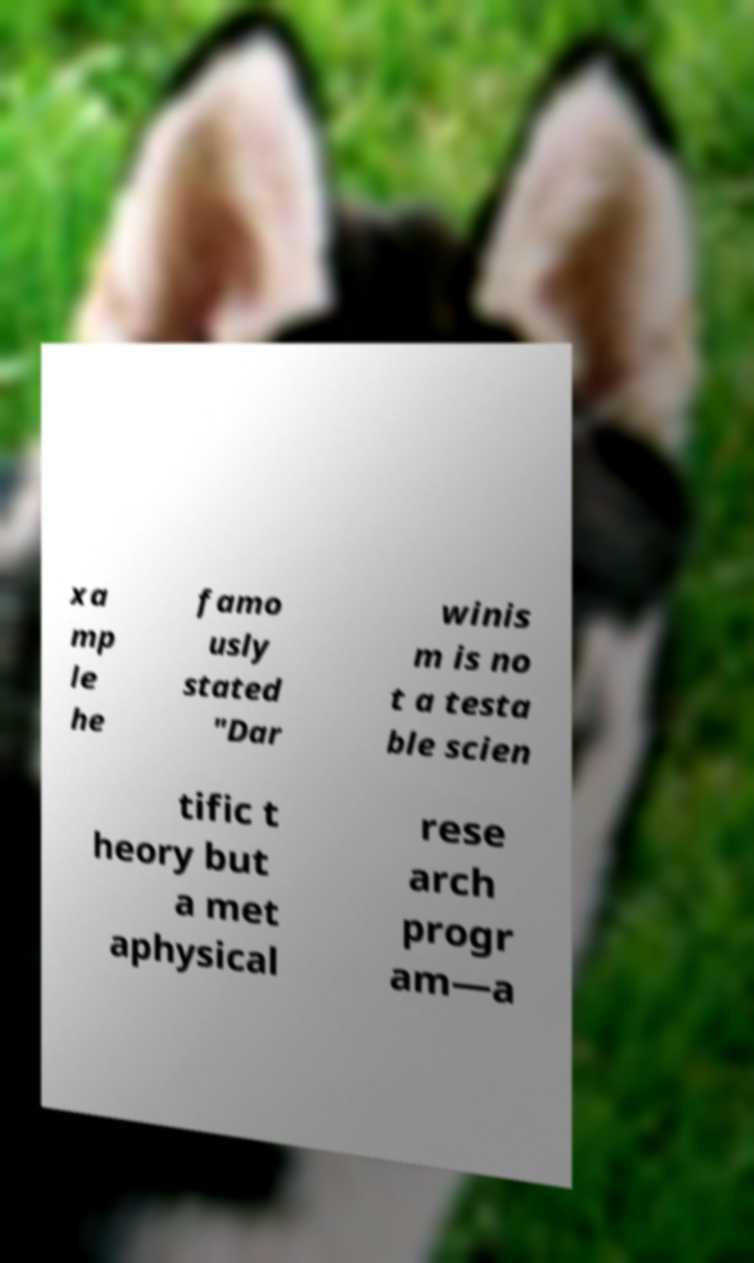Could you extract and type out the text from this image? xa mp le he famo usly stated "Dar winis m is no t a testa ble scien tific t heory but a met aphysical rese arch progr am—a 